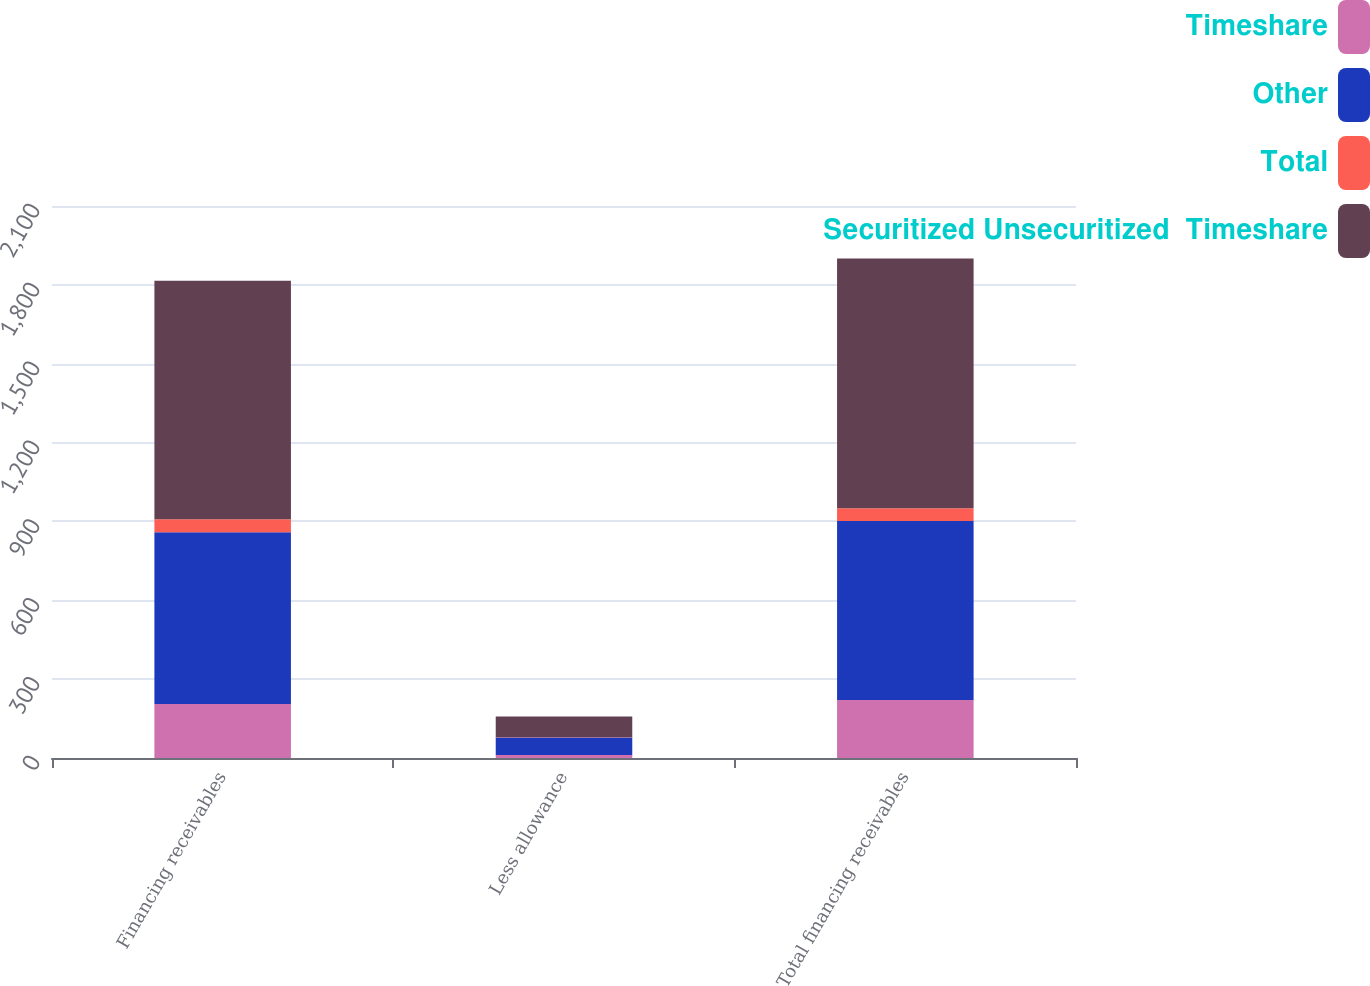Convert chart to OTSL. <chart><loc_0><loc_0><loc_500><loc_500><stacked_bar_chart><ecel><fcel>Financing receivables<fcel>Less allowance<fcel>Total financing receivables<nl><fcel>Timeshare<fcel>205<fcel>11<fcel>221<nl><fcel>Other<fcel>654<fcel>67<fcel>681<nl><fcel>Total<fcel>49<fcel>1<fcel>48<nl><fcel>Securitized Unsecuritized  Timeshare<fcel>908<fcel>79<fcel>950<nl></chart> 